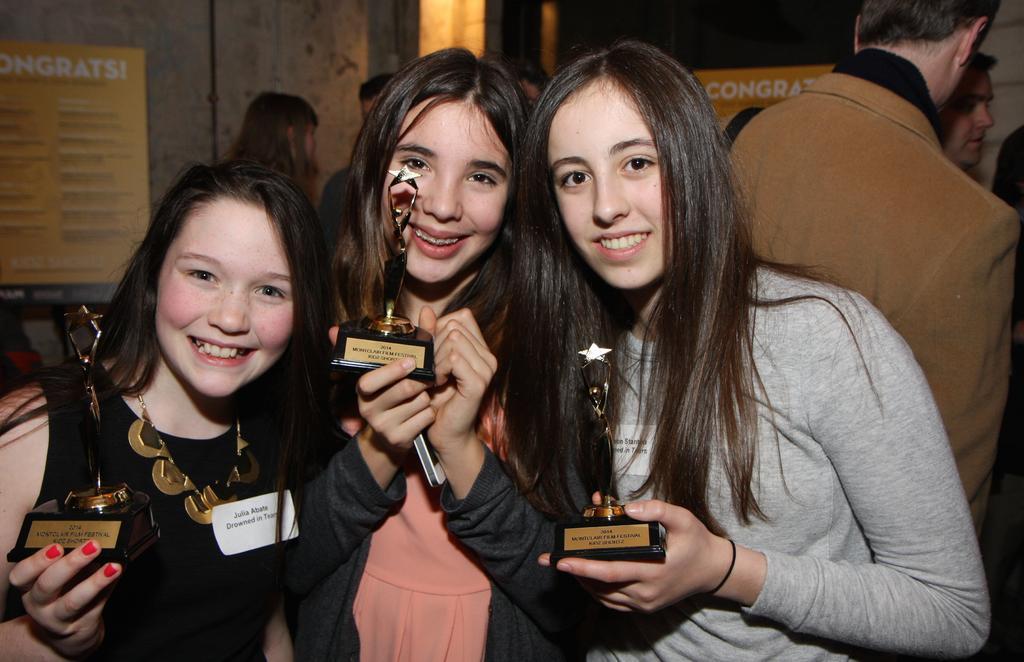Could you give a brief overview of what you see in this image? In front of the image there are three ladies standing and they are holding trophies in their hands. And they are smiling. Behind them there are few people standing. And in the background there are posters with text on it. 